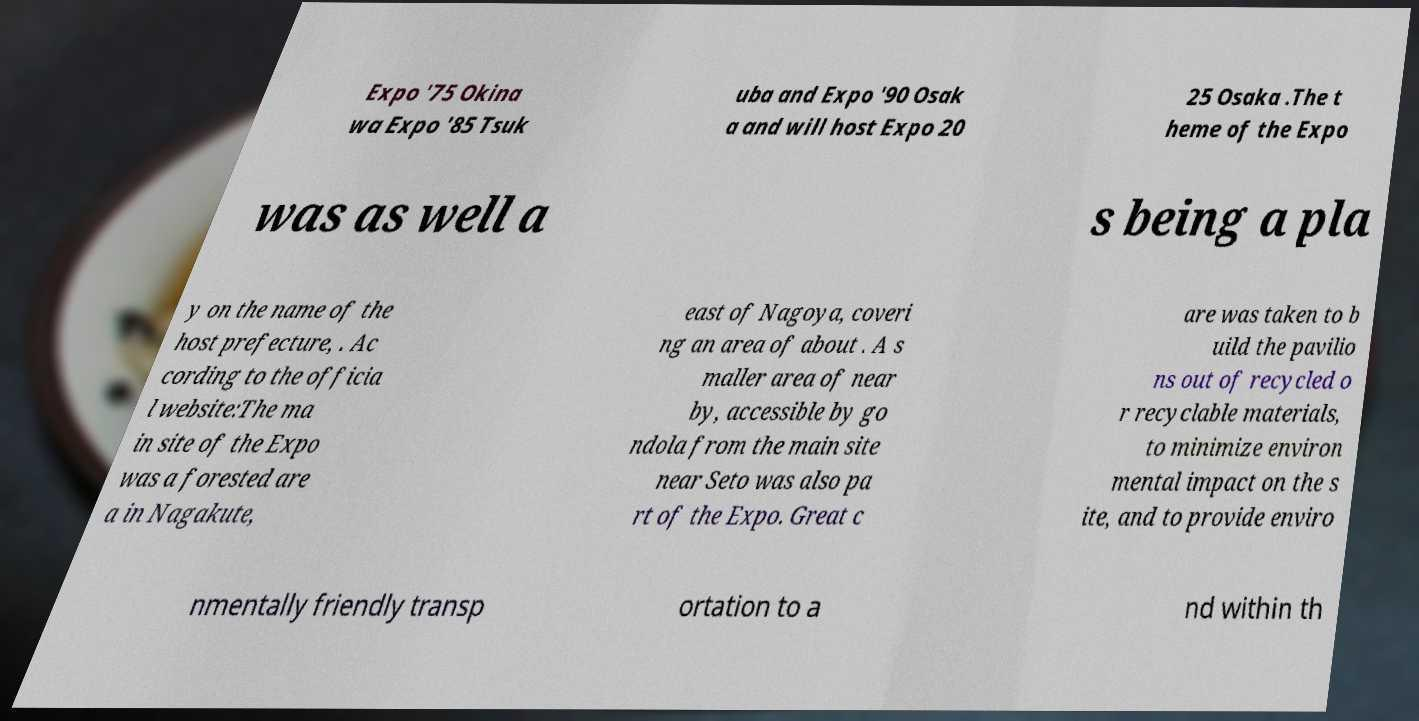Could you assist in decoding the text presented in this image and type it out clearly? Expo '75 Okina wa Expo '85 Tsuk uba and Expo '90 Osak a and will host Expo 20 25 Osaka .The t heme of the Expo was as well a s being a pla y on the name of the host prefecture, . Ac cording to the officia l website:The ma in site of the Expo was a forested are a in Nagakute, east of Nagoya, coveri ng an area of about . A s maller area of near by, accessible by go ndola from the main site near Seto was also pa rt of the Expo. Great c are was taken to b uild the pavilio ns out of recycled o r recyclable materials, to minimize environ mental impact on the s ite, and to provide enviro nmentally friendly transp ortation to a nd within th 